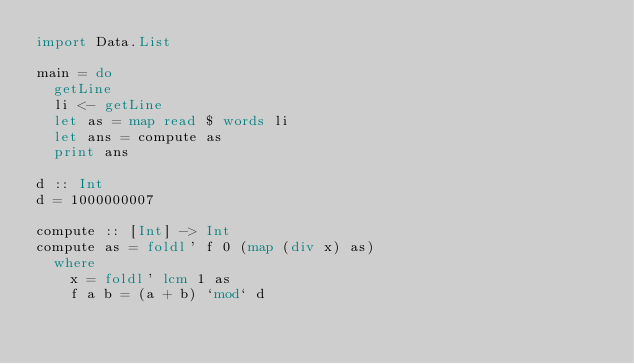<code> <loc_0><loc_0><loc_500><loc_500><_Haskell_>import Data.List

main = do
  getLine
  li <- getLine
  let as = map read $ words li
  let ans = compute as
  print ans

d :: Int
d = 1000000007

compute :: [Int] -> Int
compute as = foldl' f 0 (map (div x) as)
  where
    x = foldl' lcm 1 as
    f a b = (a + b) `mod` d
</code> 